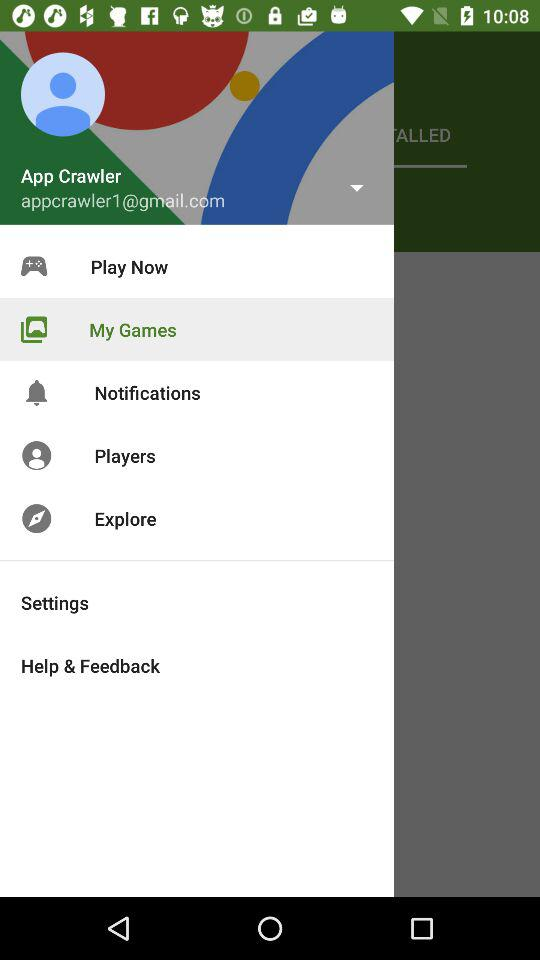How many notifications are there?
When the provided information is insufficient, respond with <no answer>. <no answer> 